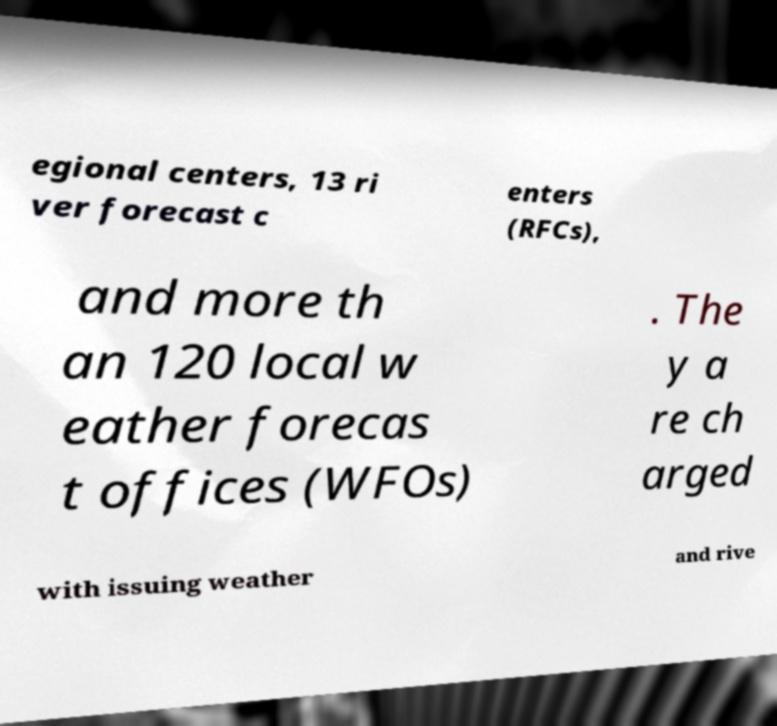I need the written content from this picture converted into text. Can you do that? egional centers, 13 ri ver forecast c enters (RFCs), and more th an 120 local w eather forecas t offices (WFOs) . The y a re ch arged with issuing weather and rive 